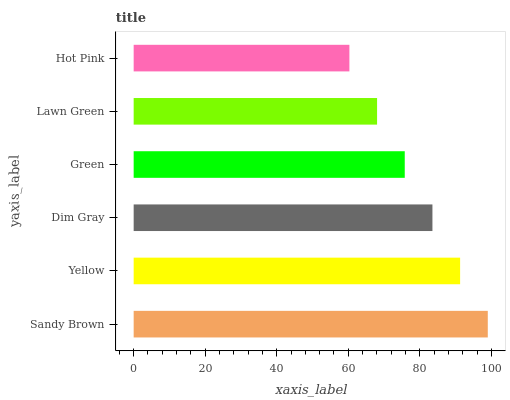Is Hot Pink the minimum?
Answer yes or no. Yes. Is Sandy Brown the maximum?
Answer yes or no. Yes. Is Yellow the minimum?
Answer yes or no. No. Is Yellow the maximum?
Answer yes or no. No. Is Sandy Brown greater than Yellow?
Answer yes or no. Yes. Is Yellow less than Sandy Brown?
Answer yes or no. Yes. Is Yellow greater than Sandy Brown?
Answer yes or no. No. Is Sandy Brown less than Yellow?
Answer yes or no. No. Is Dim Gray the high median?
Answer yes or no. Yes. Is Green the low median?
Answer yes or no. Yes. Is Hot Pink the high median?
Answer yes or no. No. Is Hot Pink the low median?
Answer yes or no. No. 